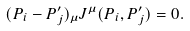<formula> <loc_0><loc_0><loc_500><loc_500>( P _ { i } - P _ { j } ^ { \prime } ) _ { \mu } J ^ { \mu } ( P _ { i } , P _ { j } ^ { \prime } ) = 0 .</formula> 